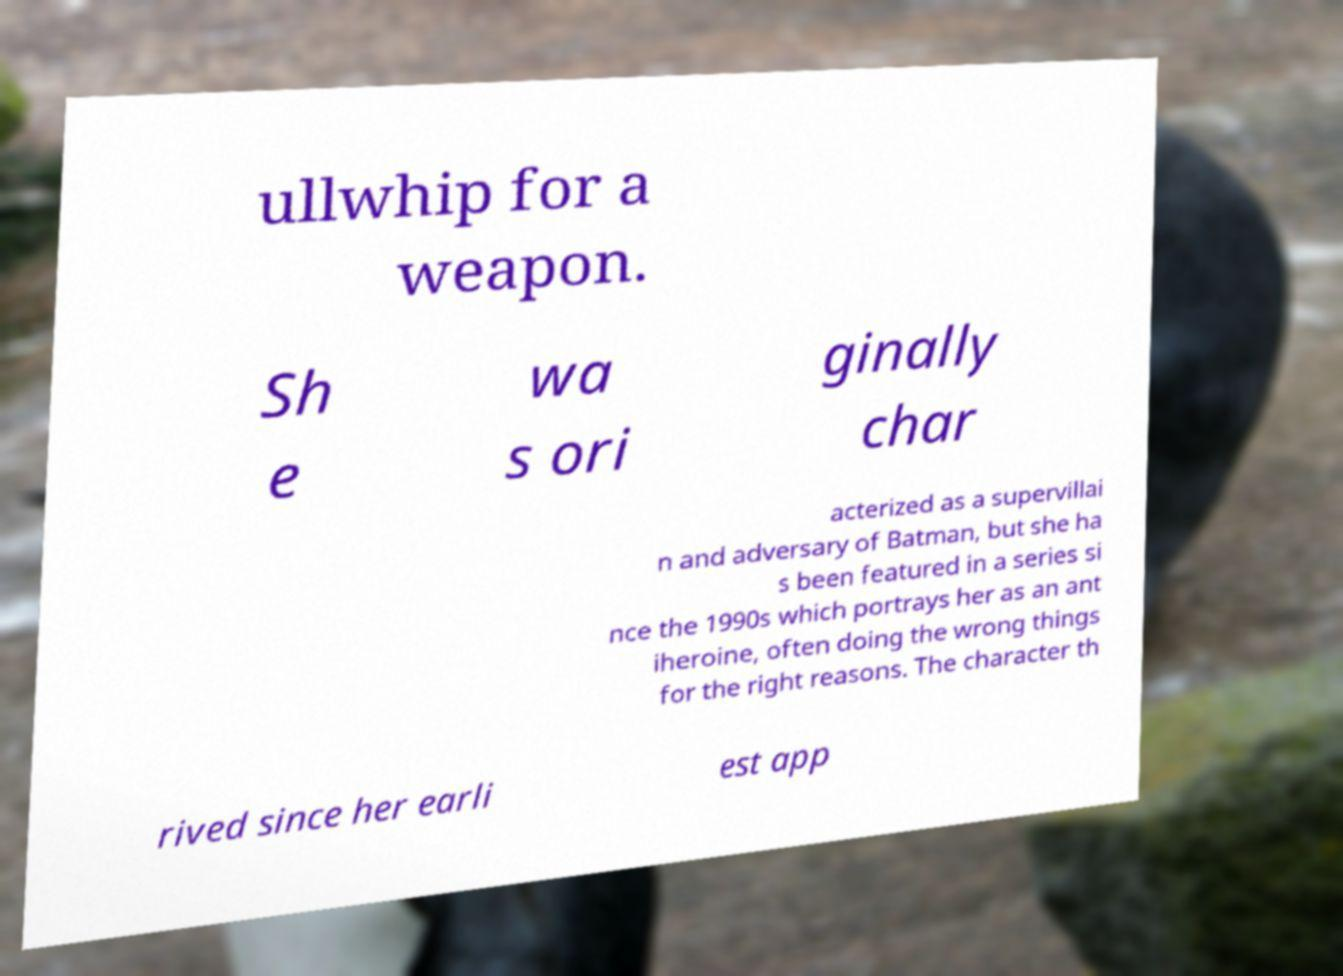Can you accurately transcribe the text from the provided image for me? ullwhip for a weapon. Sh e wa s ori ginally char acterized as a supervillai n and adversary of Batman, but she ha s been featured in a series si nce the 1990s which portrays her as an ant iheroine, often doing the wrong things for the right reasons. The character th rived since her earli est app 